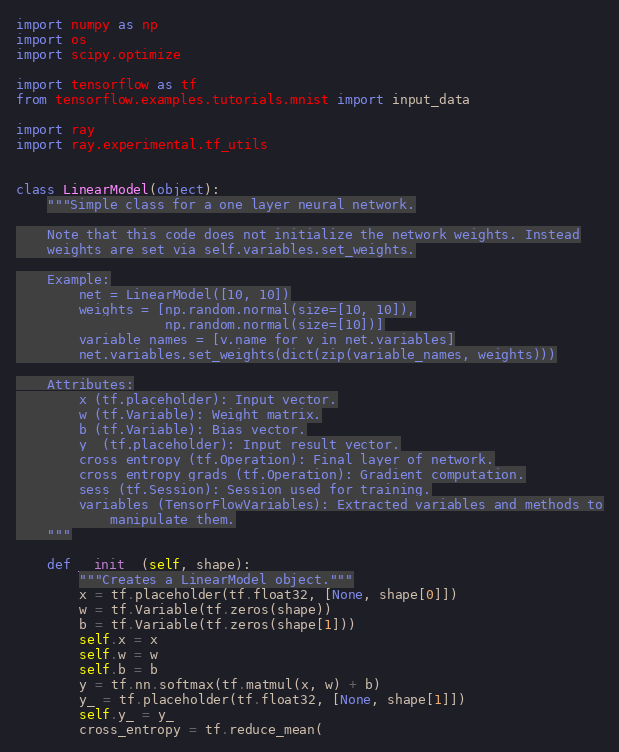<code> <loc_0><loc_0><loc_500><loc_500><_Python_>import numpy as np
import os
import scipy.optimize

import tensorflow as tf
from tensorflow.examples.tutorials.mnist import input_data

import ray
import ray.experimental.tf_utils


class LinearModel(object):
    """Simple class for a one layer neural network.

    Note that this code does not initialize the network weights. Instead
    weights are set via self.variables.set_weights.

    Example:
        net = LinearModel([10, 10])
        weights = [np.random.normal(size=[10, 10]),
                   np.random.normal(size=[10])]
        variable_names = [v.name for v in net.variables]
        net.variables.set_weights(dict(zip(variable_names, weights)))

    Attributes:
        x (tf.placeholder): Input vector.
        w (tf.Variable): Weight matrix.
        b (tf.Variable): Bias vector.
        y_ (tf.placeholder): Input result vector.
        cross_entropy (tf.Operation): Final layer of network.
        cross_entropy_grads (tf.Operation): Gradient computation.
        sess (tf.Session): Session used for training.
        variables (TensorFlowVariables): Extracted variables and methods to
            manipulate them.
    """

    def __init__(self, shape):
        """Creates a LinearModel object."""
        x = tf.placeholder(tf.float32, [None, shape[0]])
        w = tf.Variable(tf.zeros(shape))
        b = tf.Variable(tf.zeros(shape[1]))
        self.x = x
        self.w = w
        self.b = b
        y = tf.nn.softmax(tf.matmul(x, w) + b)
        y_ = tf.placeholder(tf.float32, [None, shape[1]])
        self.y_ = y_
        cross_entropy = tf.reduce_mean(</code> 